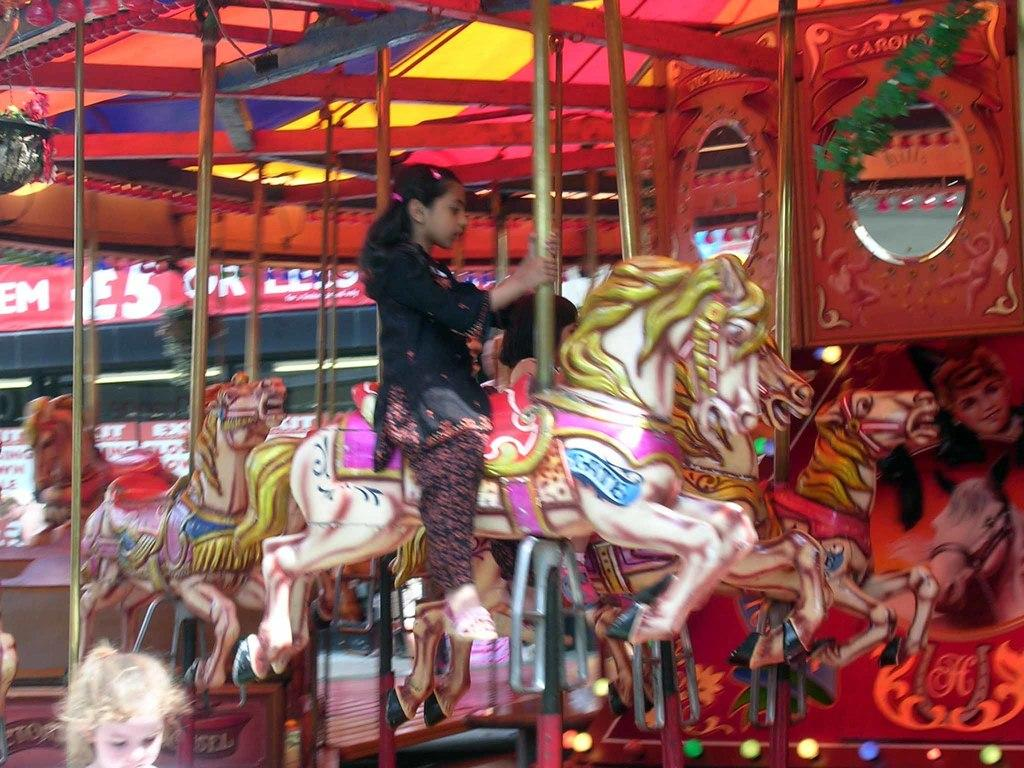What is the setting of the image? The image is taken at an exhibition. What is the girl doing in the image? The girl is sitting on a horse. What type of horse is in the image? The horse is a ride. What is the girl wearing in the image? The girl is wearing a black dress. How many jellyfish can be seen swimming in the background of the image? There are no jellyfish present in the image; it features a girl sitting on a horse at an exhibition. What force is being applied to the horse in the image? There is no indication of any force being applied to the horse in the image; the girl is simply sitting on it. 